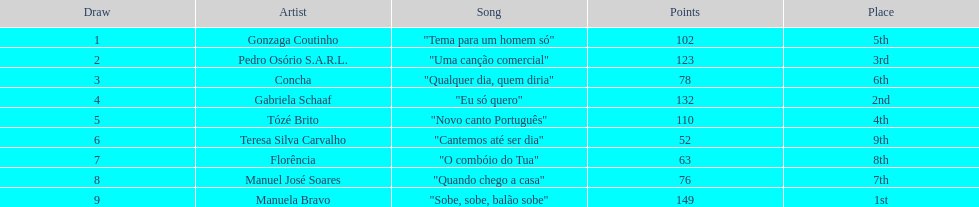Who was the artist that finished in last place? Teresa Silva Carvalho. 